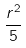Convert formula to latex. <formula><loc_0><loc_0><loc_500><loc_500>\frac { r ^ { 2 } } { 5 }</formula> 